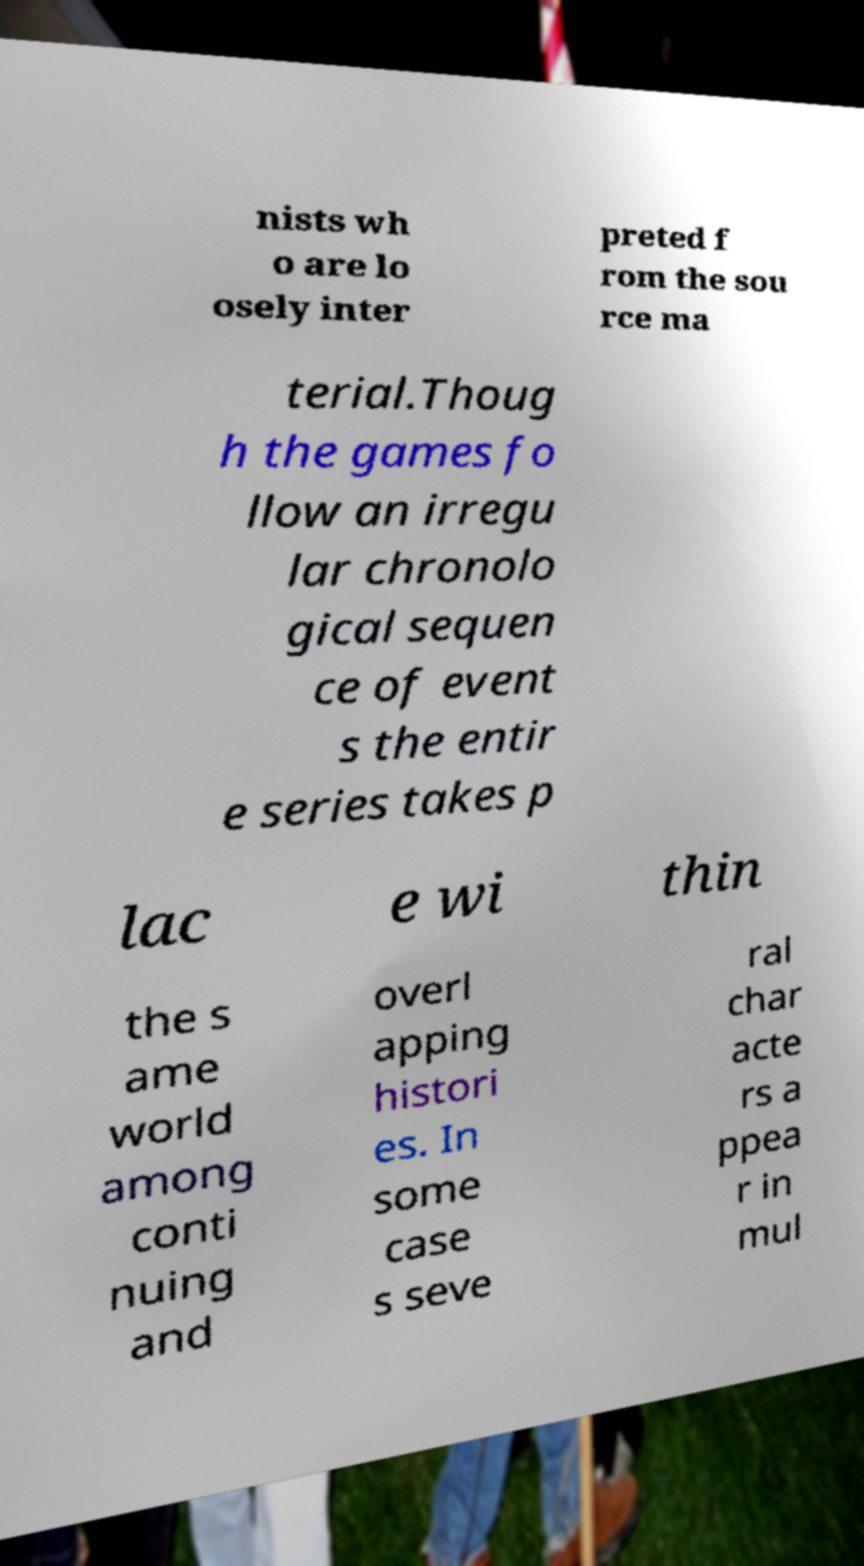What messages or text are displayed in this image? I need them in a readable, typed format. nists wh o are lo osely inter preted f rom the sou rce ma terial.Thoug h the games fo llow an irregu lar chronolo gical sequen ce of event s the entir e series takes p lac e wi thin the s ame world among conti nuing and overl apping histori es. In some case s seve ral char acte rs a ppea r in mul 